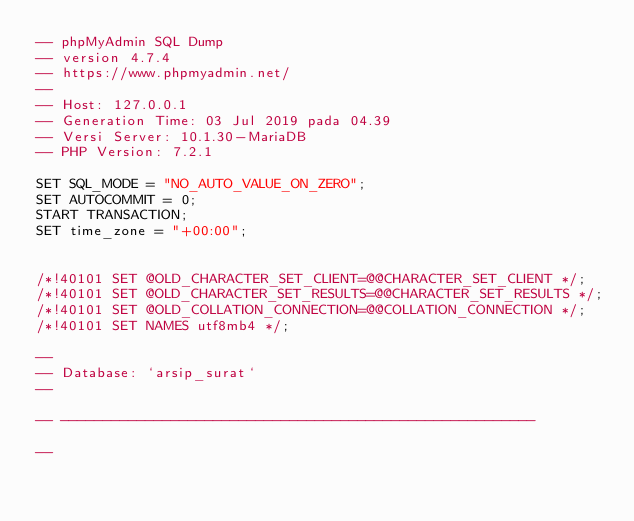Convert code to text. <code><loc_0><loc_0><loc_500><loc_500><_SQL_>-- phpMyAdmin SQL Dump
-- version 4.7.4
-- https://www.phpmyadmin.net/
--
-- Host: 127.0.0.1
-- Generation Time: 03 Jul 2019 pada 04.39
-- Versi Server: 10.1.30-MariaDB
-- PHP Version: 7.2.1

SET SQL_MODE = "NO_AUTO_VALUE_ON_ZERO";
SET AUTOCOMMIT = 0;
START TRANSACTION;
SET time_zone = "+00:00";


/*!40101 SET @OLD_CHARACTER_SET_CLIENT=@@CHARACTER_SET_CLIENT */;
/*!40101 SET @OLD_CHARACTER_SET_RESULTS=@@CHARACTER_SET_RESULTS */;
/*!40101 SET @OLD_COLLATION_CONNECTION=@@COLLATION_CONNECTION */;
/*!40101 SET NAMES utf8mb4 */;

--
-- Database: `arsip_surat`
--

-- --------------------------------------------------------

--</code> 